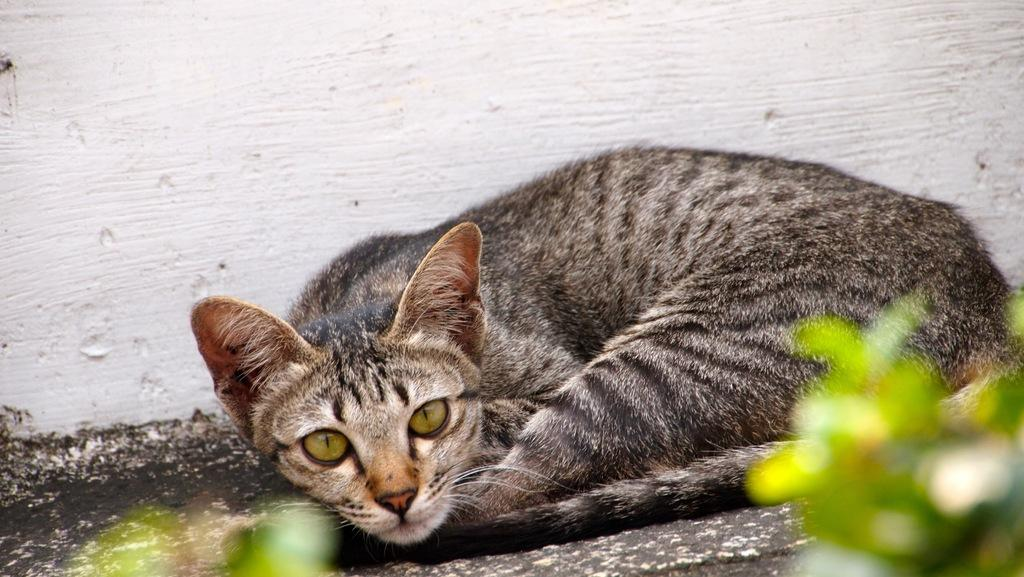What animal is lying on the ground in the image? There is a cat lying on the ground in the image. What can be seen in the background of the image? There is a wall visible in the background of the image. What type of paint is the cat using to create a masterpiece in the image? There is no paint or masterpiece present in the image; it simply features a cat lying on the ground. 